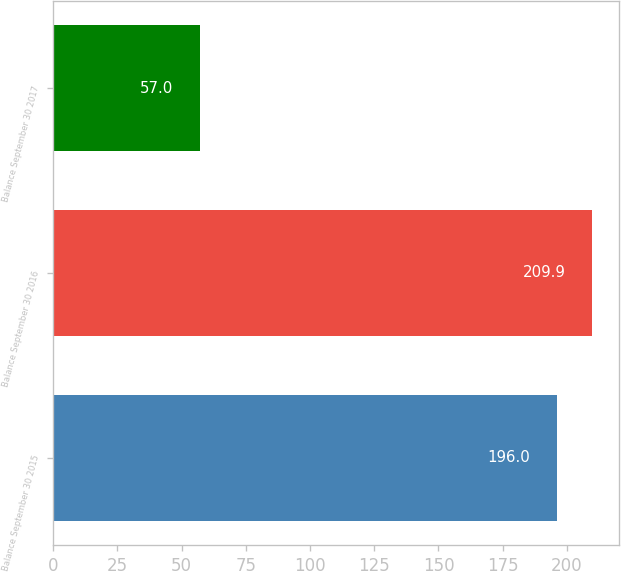Convert chart. <chart><loc_0><loc_0><loc_500><loc_500><bar_chart><fcel>Balance September 30 2015<fcel>Balance September 30 2016<fcel>Balance September 30 2017<nl><fcel>196<fcel>209.9<fcel>57<nl></chart> 